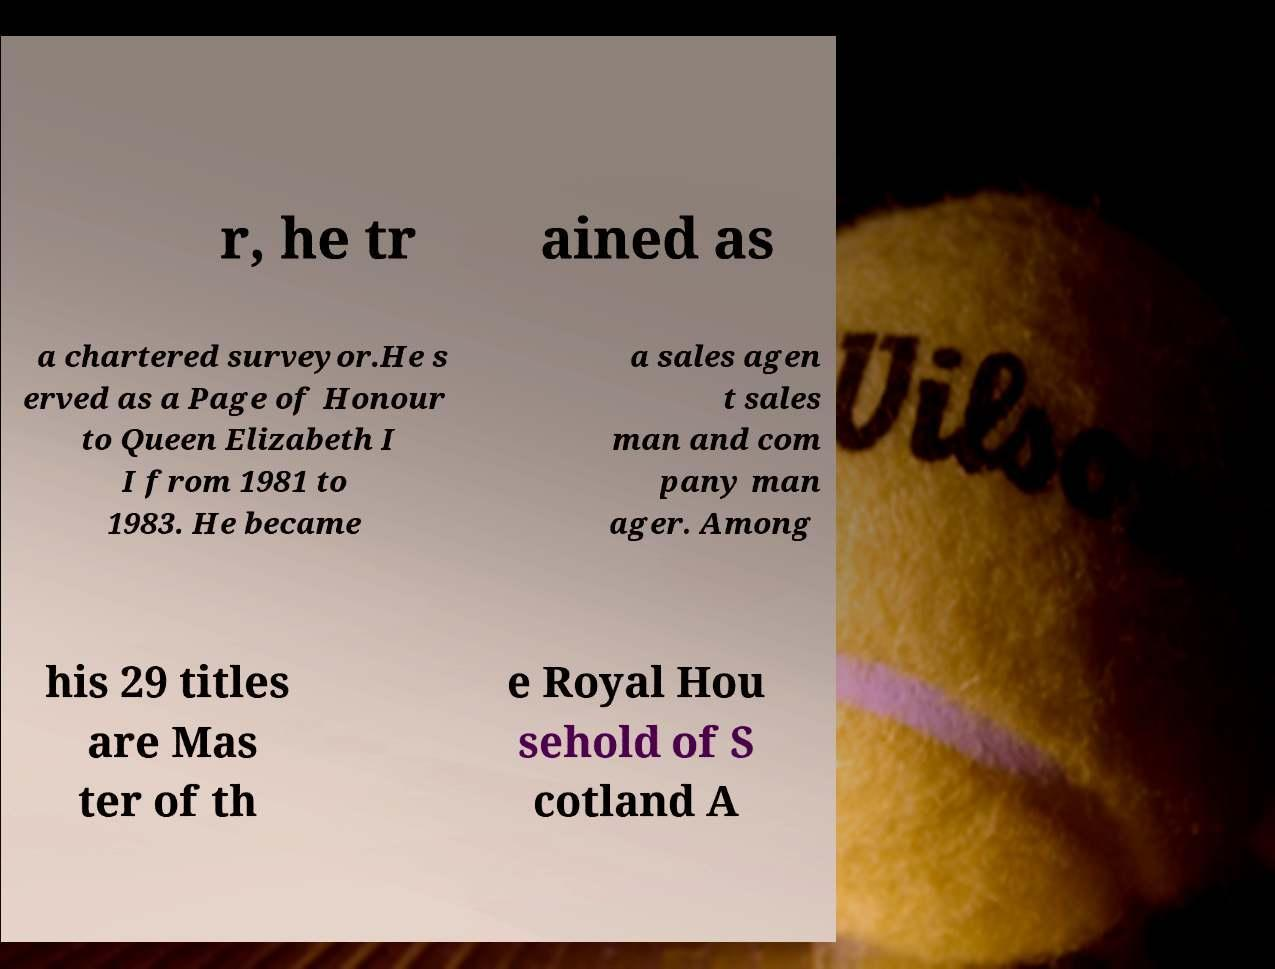Please identify and transcribe the text found in this image. r, he tr ained as a chartered surveyor.He s erved as a Page of Honour to Queen Elizabeth I I from 1981 to 1983. He became a sales agen t sales man and com pany man ager. Among his 29 titles are Mas ter of th e Royal Hou sehold of S cotland A 